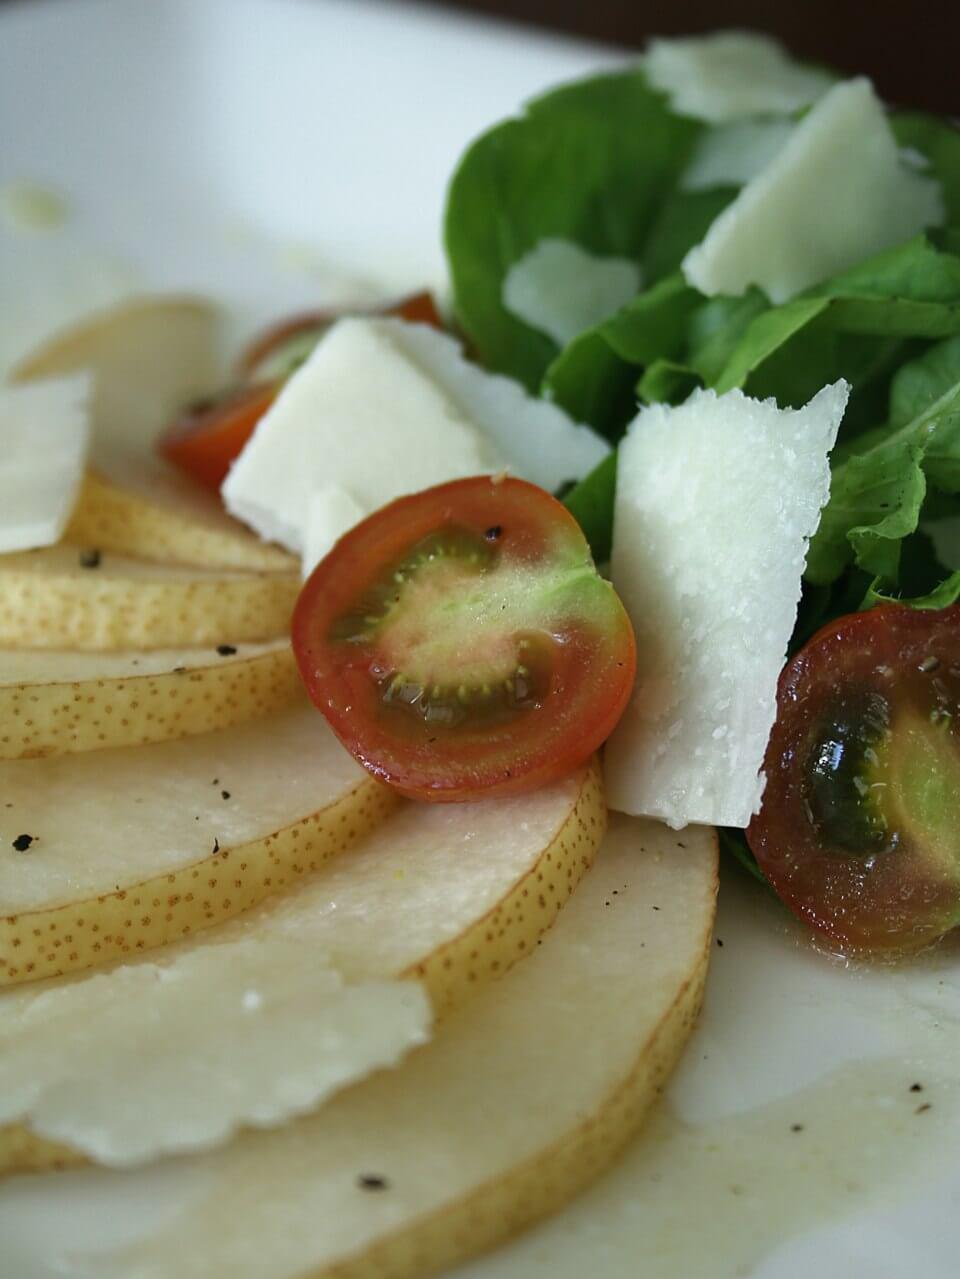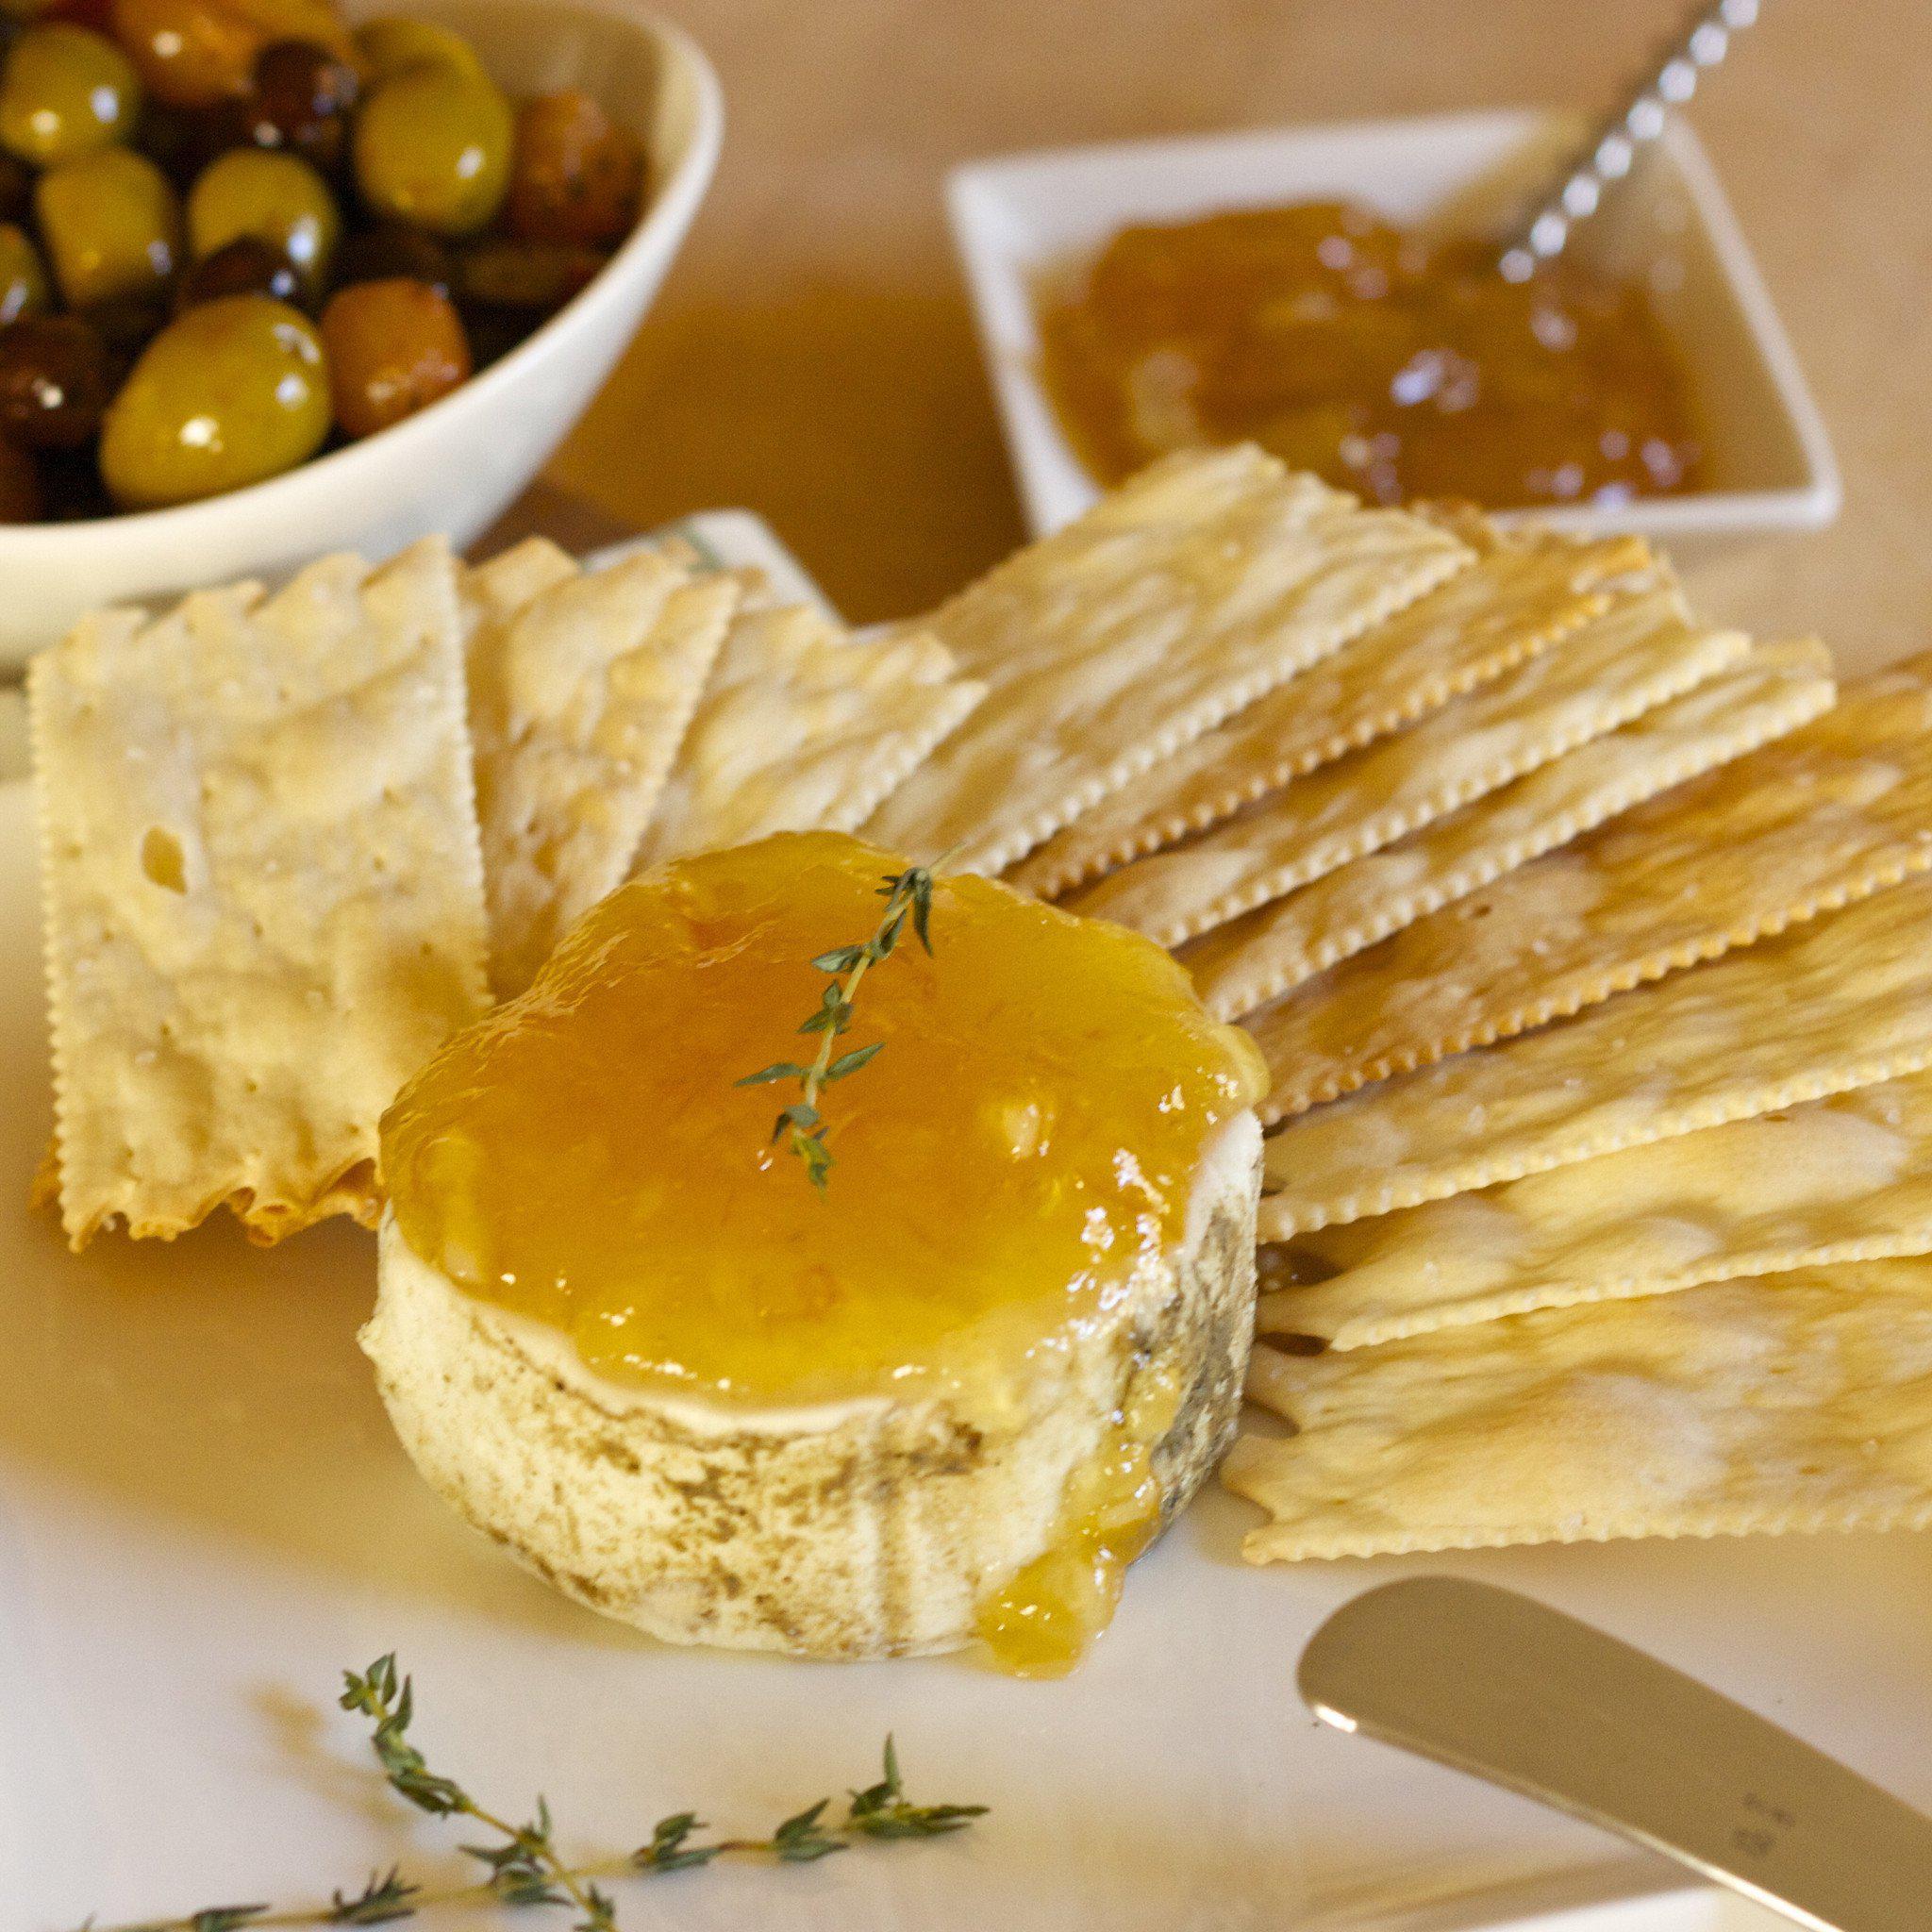The first image is the image on the left, the second image is the image on the right. For the images displayed, is the sentence "In one of the images, there is a piece of fresh lemon sitting beside the dough." factually correct? Answer yes or no. No. The first image is the image on the left, the second image is the image on the right. Given the left and right images, does the statement "there is cake with lemons being used as decorations and a metal utencil is near the cake" hold true? Answer yes or no. No. 